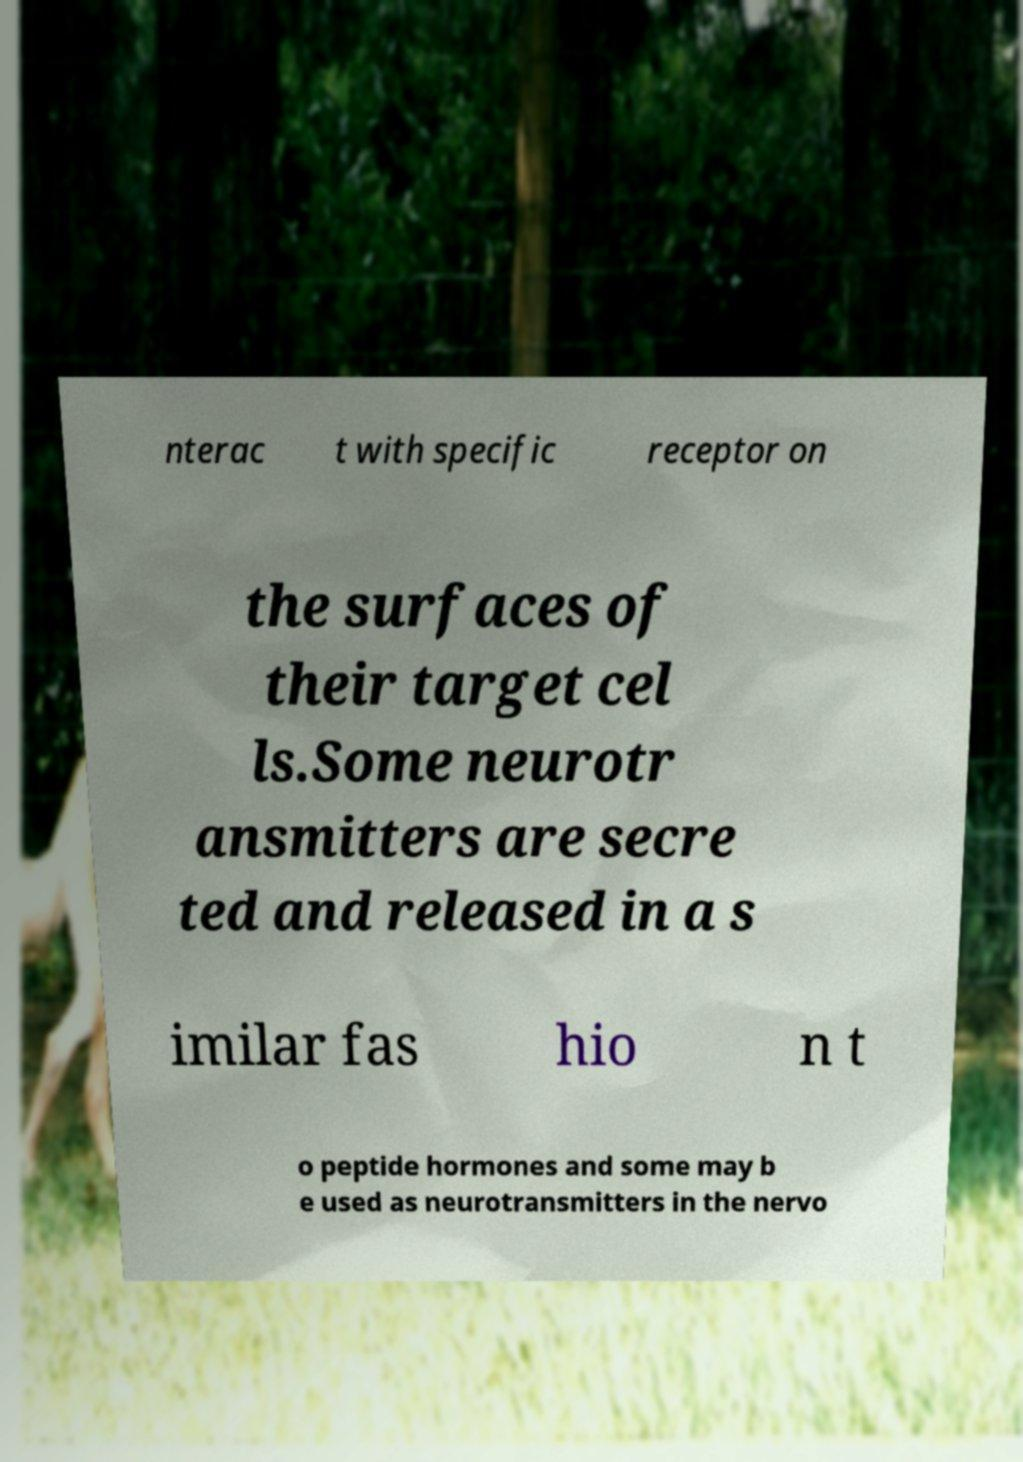Can you read and provide the text displayed in the image?This photo seems to have some interesting text. Can you extract and type it out for me? nterac t with specific receptor on the surfaces of their target cel ls.Some neurotr ansmitters are secre ted and released in a s imilar fas hio n t o peptide hormones and some may b e used as neurotransmitters in the nervo 